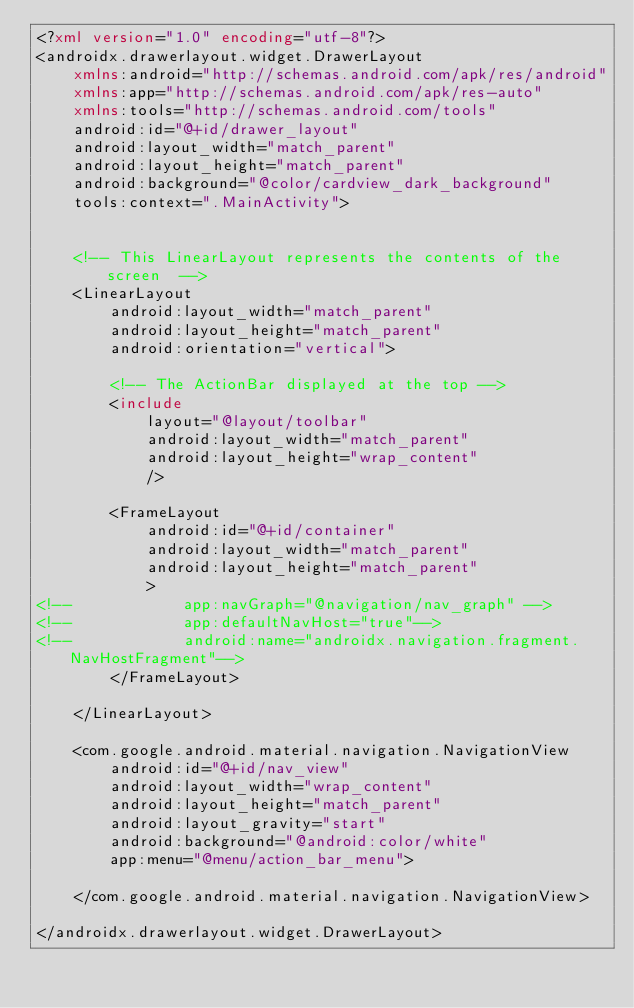Convert code to text. <code><loc_0><loc_0><loc_500><loc_500><_XML_><?xml version="1.0" encoding="utf-8"?>
<androidx.drawerlayout.widget.DrawerLayout
    xmlns:android="http://schemas.android.com/apk/res/android"
    xmlns:app="http://schemas.android.com/apk/res-auto"
    xmlns:tools="http://schemas.android.com/tools"
    android:id="@+id/drawer_layout"
    android:layout_width="match_parent"
    android:layout_height="match_parent"
    android:background="@color/cardview_dark_background"
    tools:context=".MainActivity">


    <!-- This LinearLayout represents the contents of the screen  -->
    <LinearLayout
        android:layout_width="match_parent"
        android:layout_height="match_parent"
        android:orientation="vertical">

        <!-- The ActionBar displayed at the top -->
        <include
            layout="@layout/toolbar"
            android:layout_width="match_parent"
            android:layout_height="wrap_content"
            />

        <FrameLayout
            android:id="@+id/container"
            android:layout_width="match_parent"
            android:layout_height="match_parent"
            >
<!--            app:navGraph="@navigation/nav_graph" -->
<!--            app:defaultNavHost="true"-->
<!--            android:name="androidx.navigation.fragment.NavHostFragment"-->
        </FrameLayout>

    </LinearLayout>

    <com.google.android.material.navigation.NavigationView
        android:id="@+id/nav_view"
        android:layout_width="wrap_content"
        android:layout_height="match_parent"
        android:layout_gravity="start"
        android:background="@android:color/white"
        app:menu="@menu/action_bar_menu">

    </com.google.android.material.navigation.NavigationView>

</androidx.drawerlayout.widget.DrawerLayout></code> 